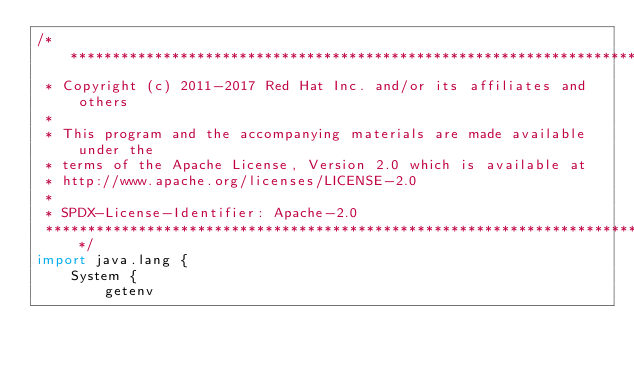<code> <loc_0><loc_0><loc_500><loc_500><_Ceylon_>/********************************************************************************
 * Copyright (c) 2011-2017 Red Hat Inc. and/or its affiliates and others
 *
 * This program and the accompanying materials are made available under the 
 * terms of the Apache License, Version 2.0 which is available at
 * http://www.apache.org/licenses/LICENSE-2.0
 *
 * SPDX-License-Identifier: Apache-2.0 
 ********************************************************************************/
import java.lang {
    System {
        getenv</code> 